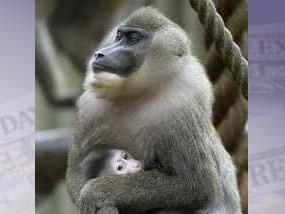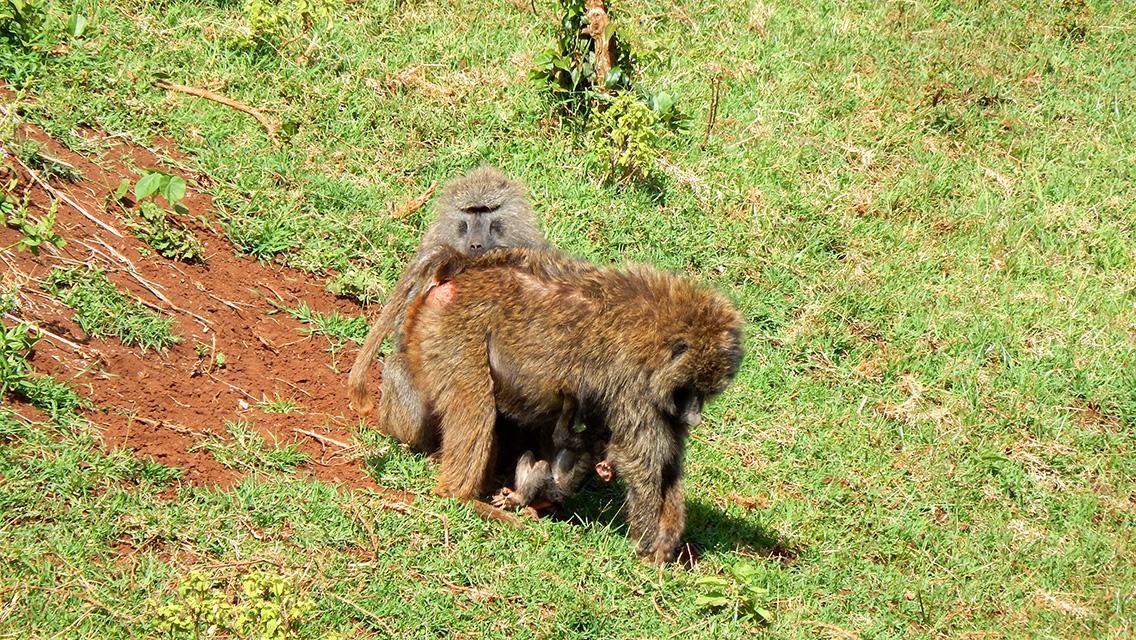The first image is the image on the left, the second image is the image on the right. Examine the images to the left and right. Is the description "There is a single monkey looking in the direction of the camera in the image on the right." accurate? Answer yes or no. No. The first image is the image on the left, the second image is the image on the right. Evaluate the accuracy of this statement regarding the images: "An image shows a juvenile baboon posed with its chest against the chest of an adult baboon.". Is it true? Answer yes or no. Yes. 